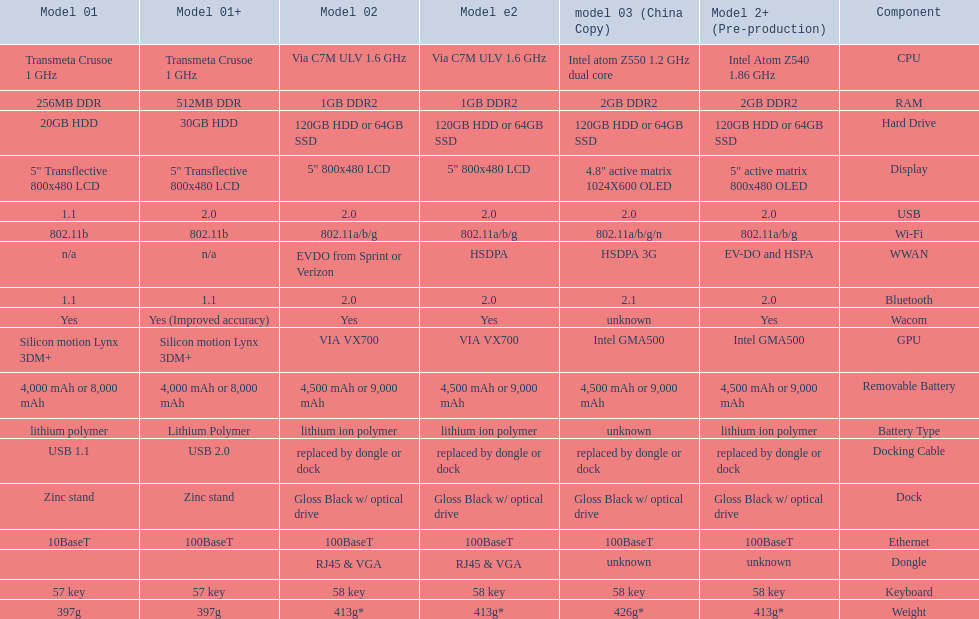What is the total number of components on the chart? 18. 